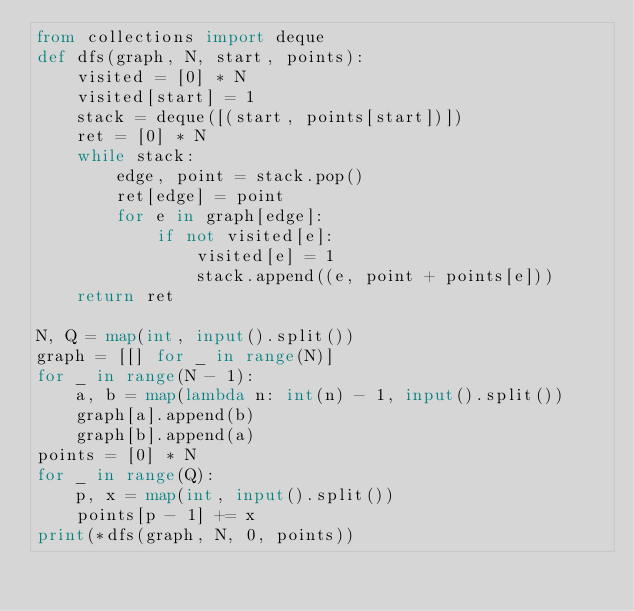Convert code to text. <code><loc_0><loc_0><loc_500><loc_500><_Python_>from collections import deque
def dfs(graph, N, start, points):
    visited = [0] * N
    visited[start] = 1
    stack = deque([(start, points[start])])
    ret = [0] * N
    while stack:
        edge, point = stack.pop()
        ret[edge] = point
        for e in graph[edge]:
            if not visited[e]:
                visited[e] = 1
                stack.append((e, point + points[e]))
    return ret

N, Q = map(int, input().split())
graph = [[] for _ in range(N)]
for _ in range(N - 1):
    a, b = map(lambda n: int(n) - 1, input().split())
    graph[a].append(b)
    graph[b].append(a)
points = [0] * N
for _ in range(Q):
    p, x = map(int, input().split())
    points[p - 1] += x
print(*dfs(graph, N, 0, points))</code> 